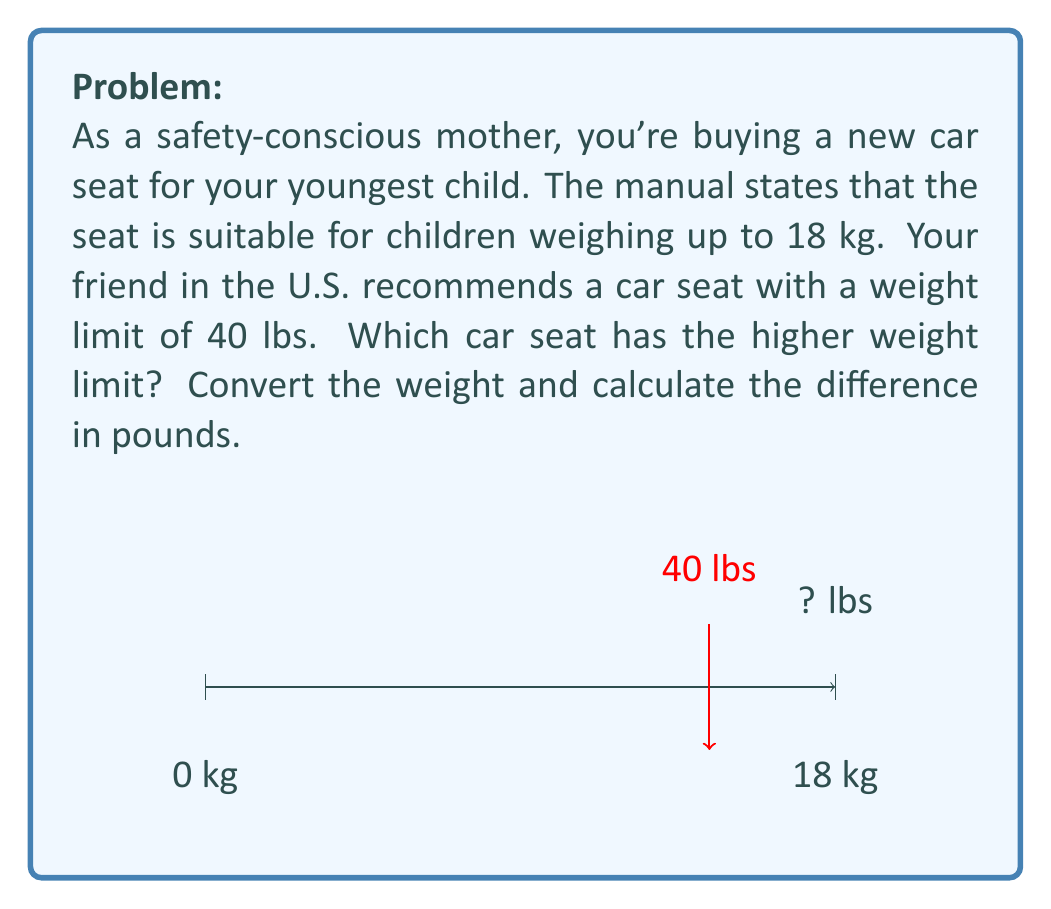Can you answer this question? To solve this problem, we need to convert 18 kg to pounds and compare it with 40 lbs. Let's follow these steps:

1) First, let's recall the conversion factor:
   1 kg ≈ 2.20462 lbs

2) Now, let's convert 18 kg to pounds:
   $18 \text{ kg} \times 2.20462 \frac{\text{lbs}}{\text{kg}} = 39.68316 \text{ lbs}$

3) We can round this to 39.68 lbs for practical purposes.

4) Now we can compare:
   18 kg ≈ 39.68 lbs < 40 lbs

5) To find the difference, we subtract:
   $40 \text{ lbs} - 39.68316 \text{ lbs} = 0.31684 \text{ lbs}$

6) Rounding to two decimal places:
   Difference ≈ 0.32 lbs

Therefore, the car seat recommended by your friend in the U.S. has a slightly higher weight limit.
Answer: 40 lbs seat; 0.32 lbs higher 